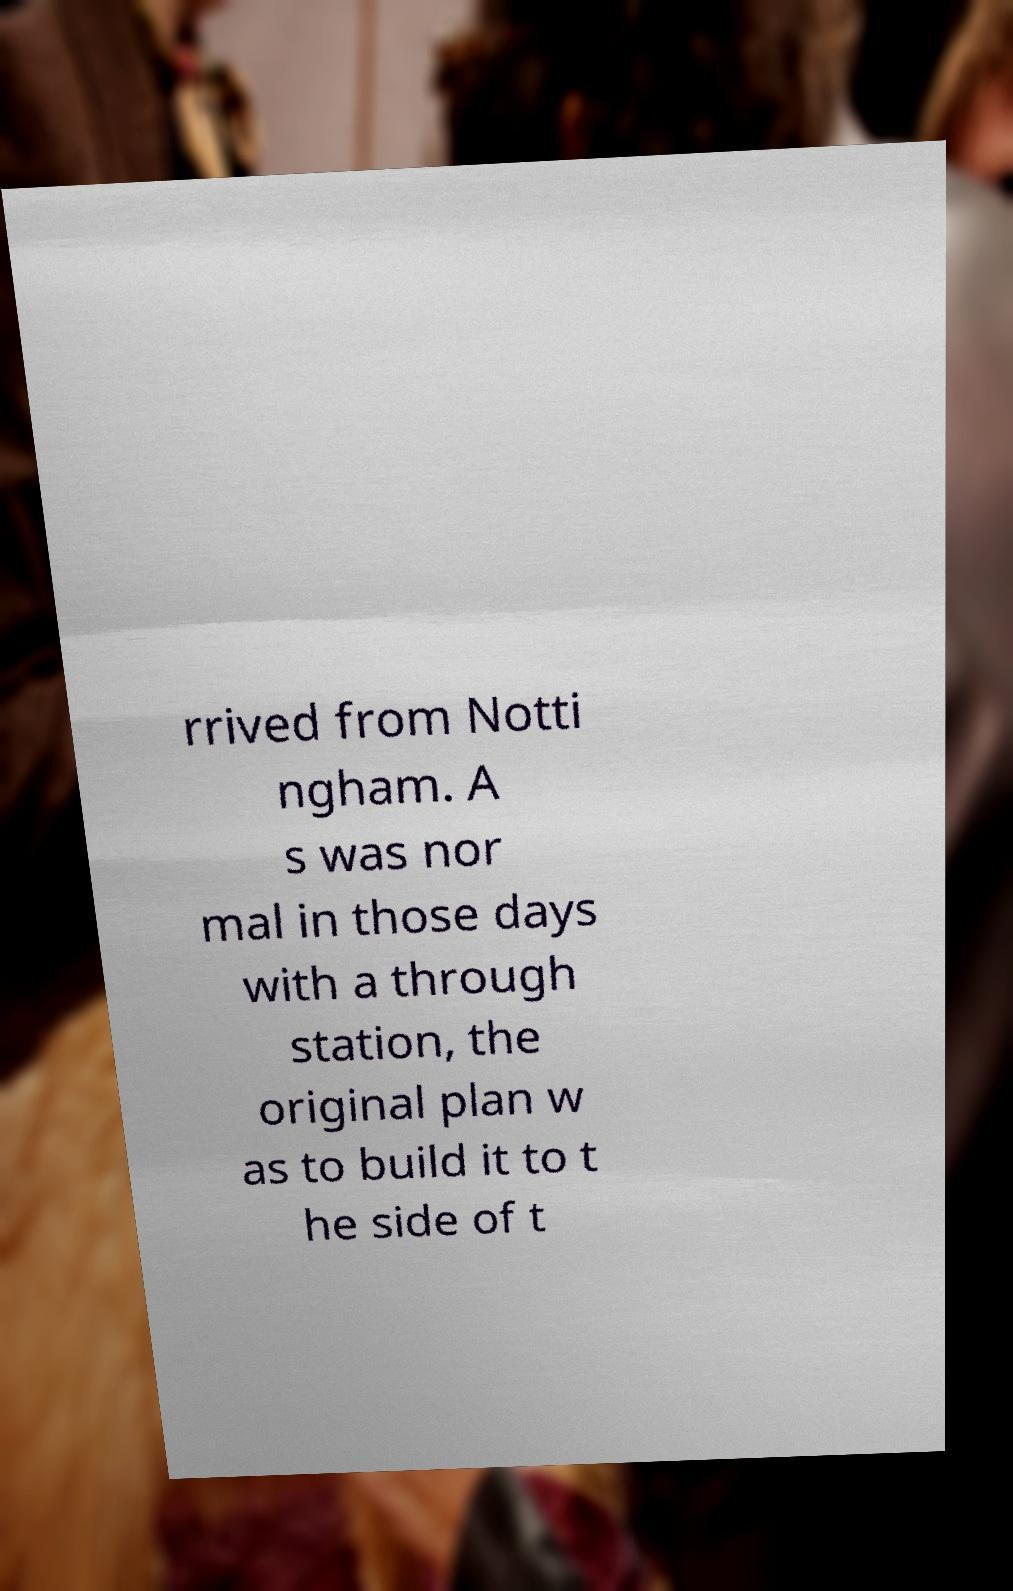Could you assist in decoding the text presented in this image and type it out clearly? rrived from Notti ngham. A s was nor mal in those days with a through station, the original plan w as to build it to t he side of t 